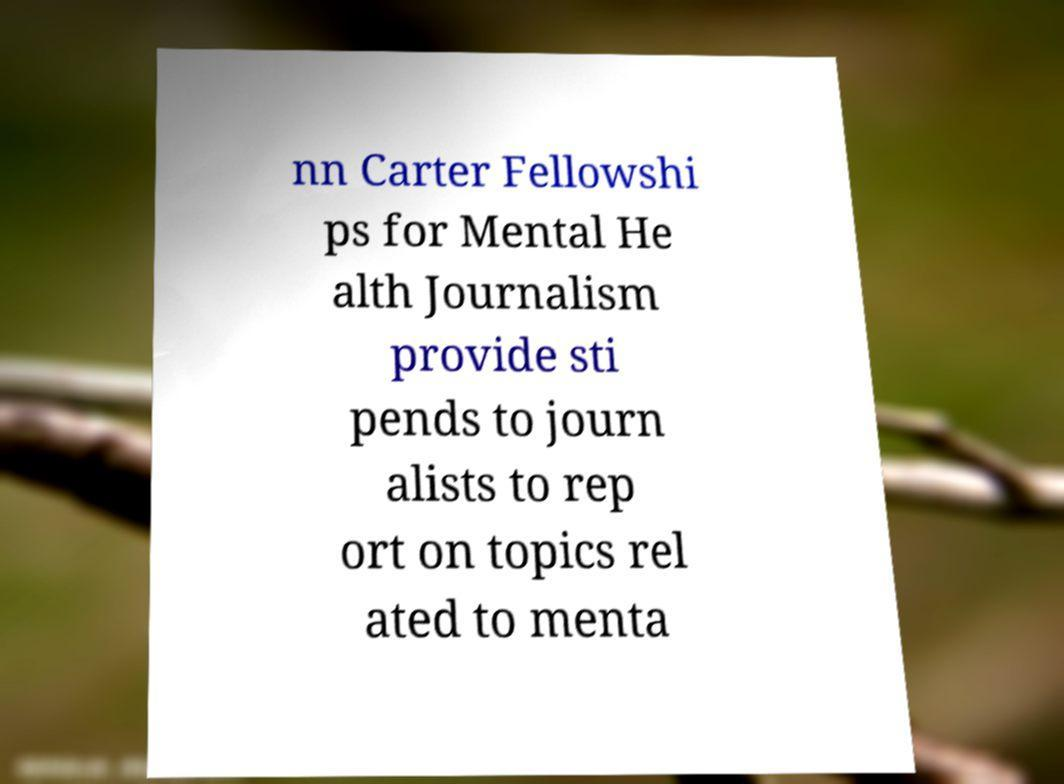Could you assist in decoding the text presented in this image and type it out clearly? nn Carter Fellowshi ps for Mental He alth Journalism provide sti pends to journ alists to rep ort on topics rel ated to menta 